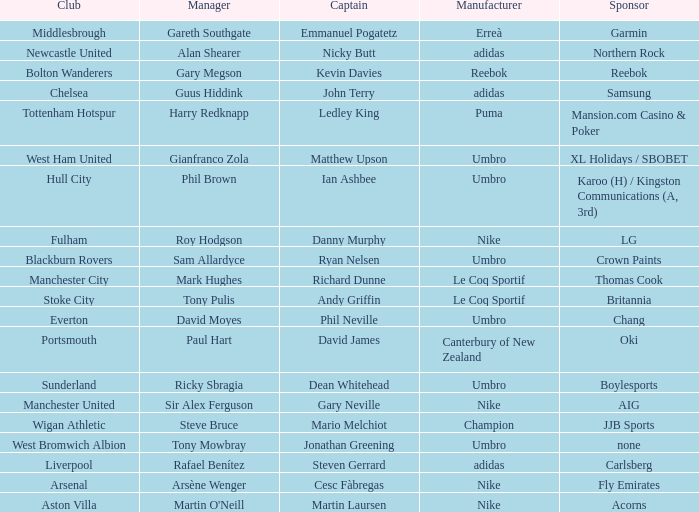Who is Dean Whitehead's manager? Ricky Sbragia. 